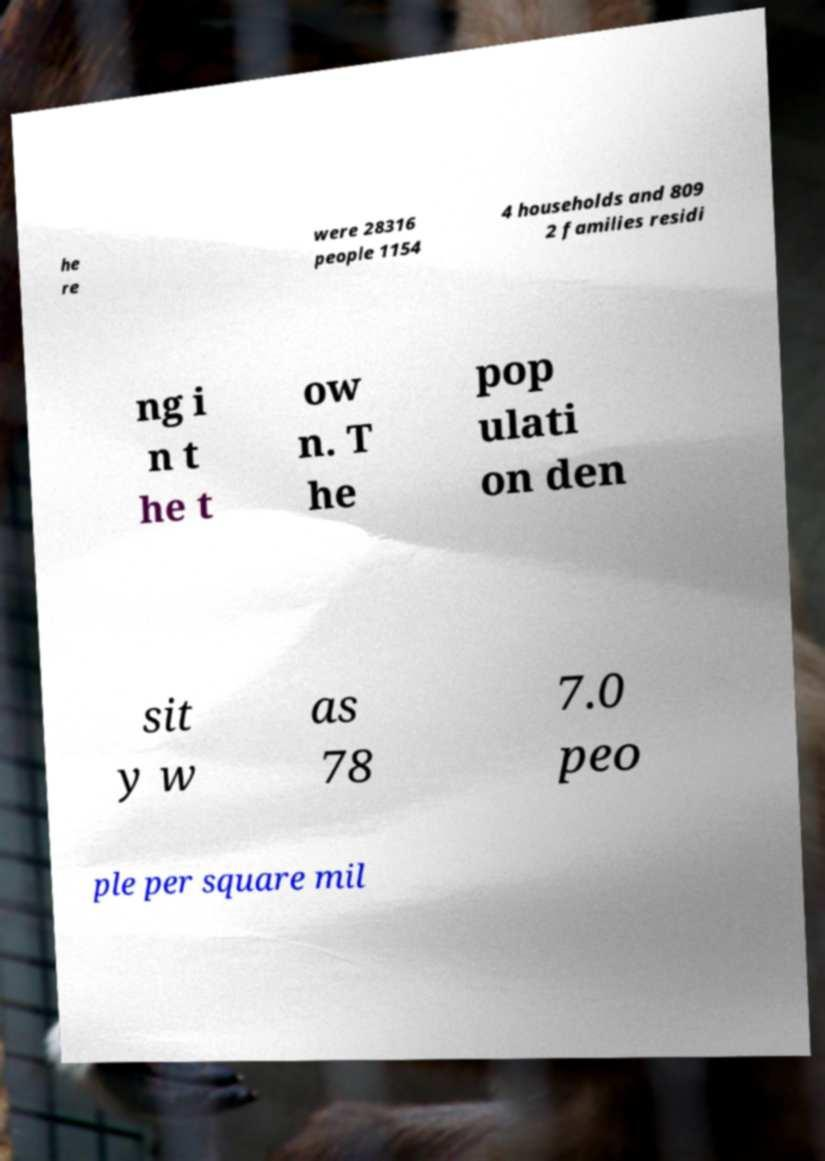Please read and relay the text visible in this image. What does it say? he re were 28316 people 1154 4 households and 809 2 families residi ng i n t he t ow n. T he pop ulati on den sit y w as 78 7.0 peo ple per square mil 